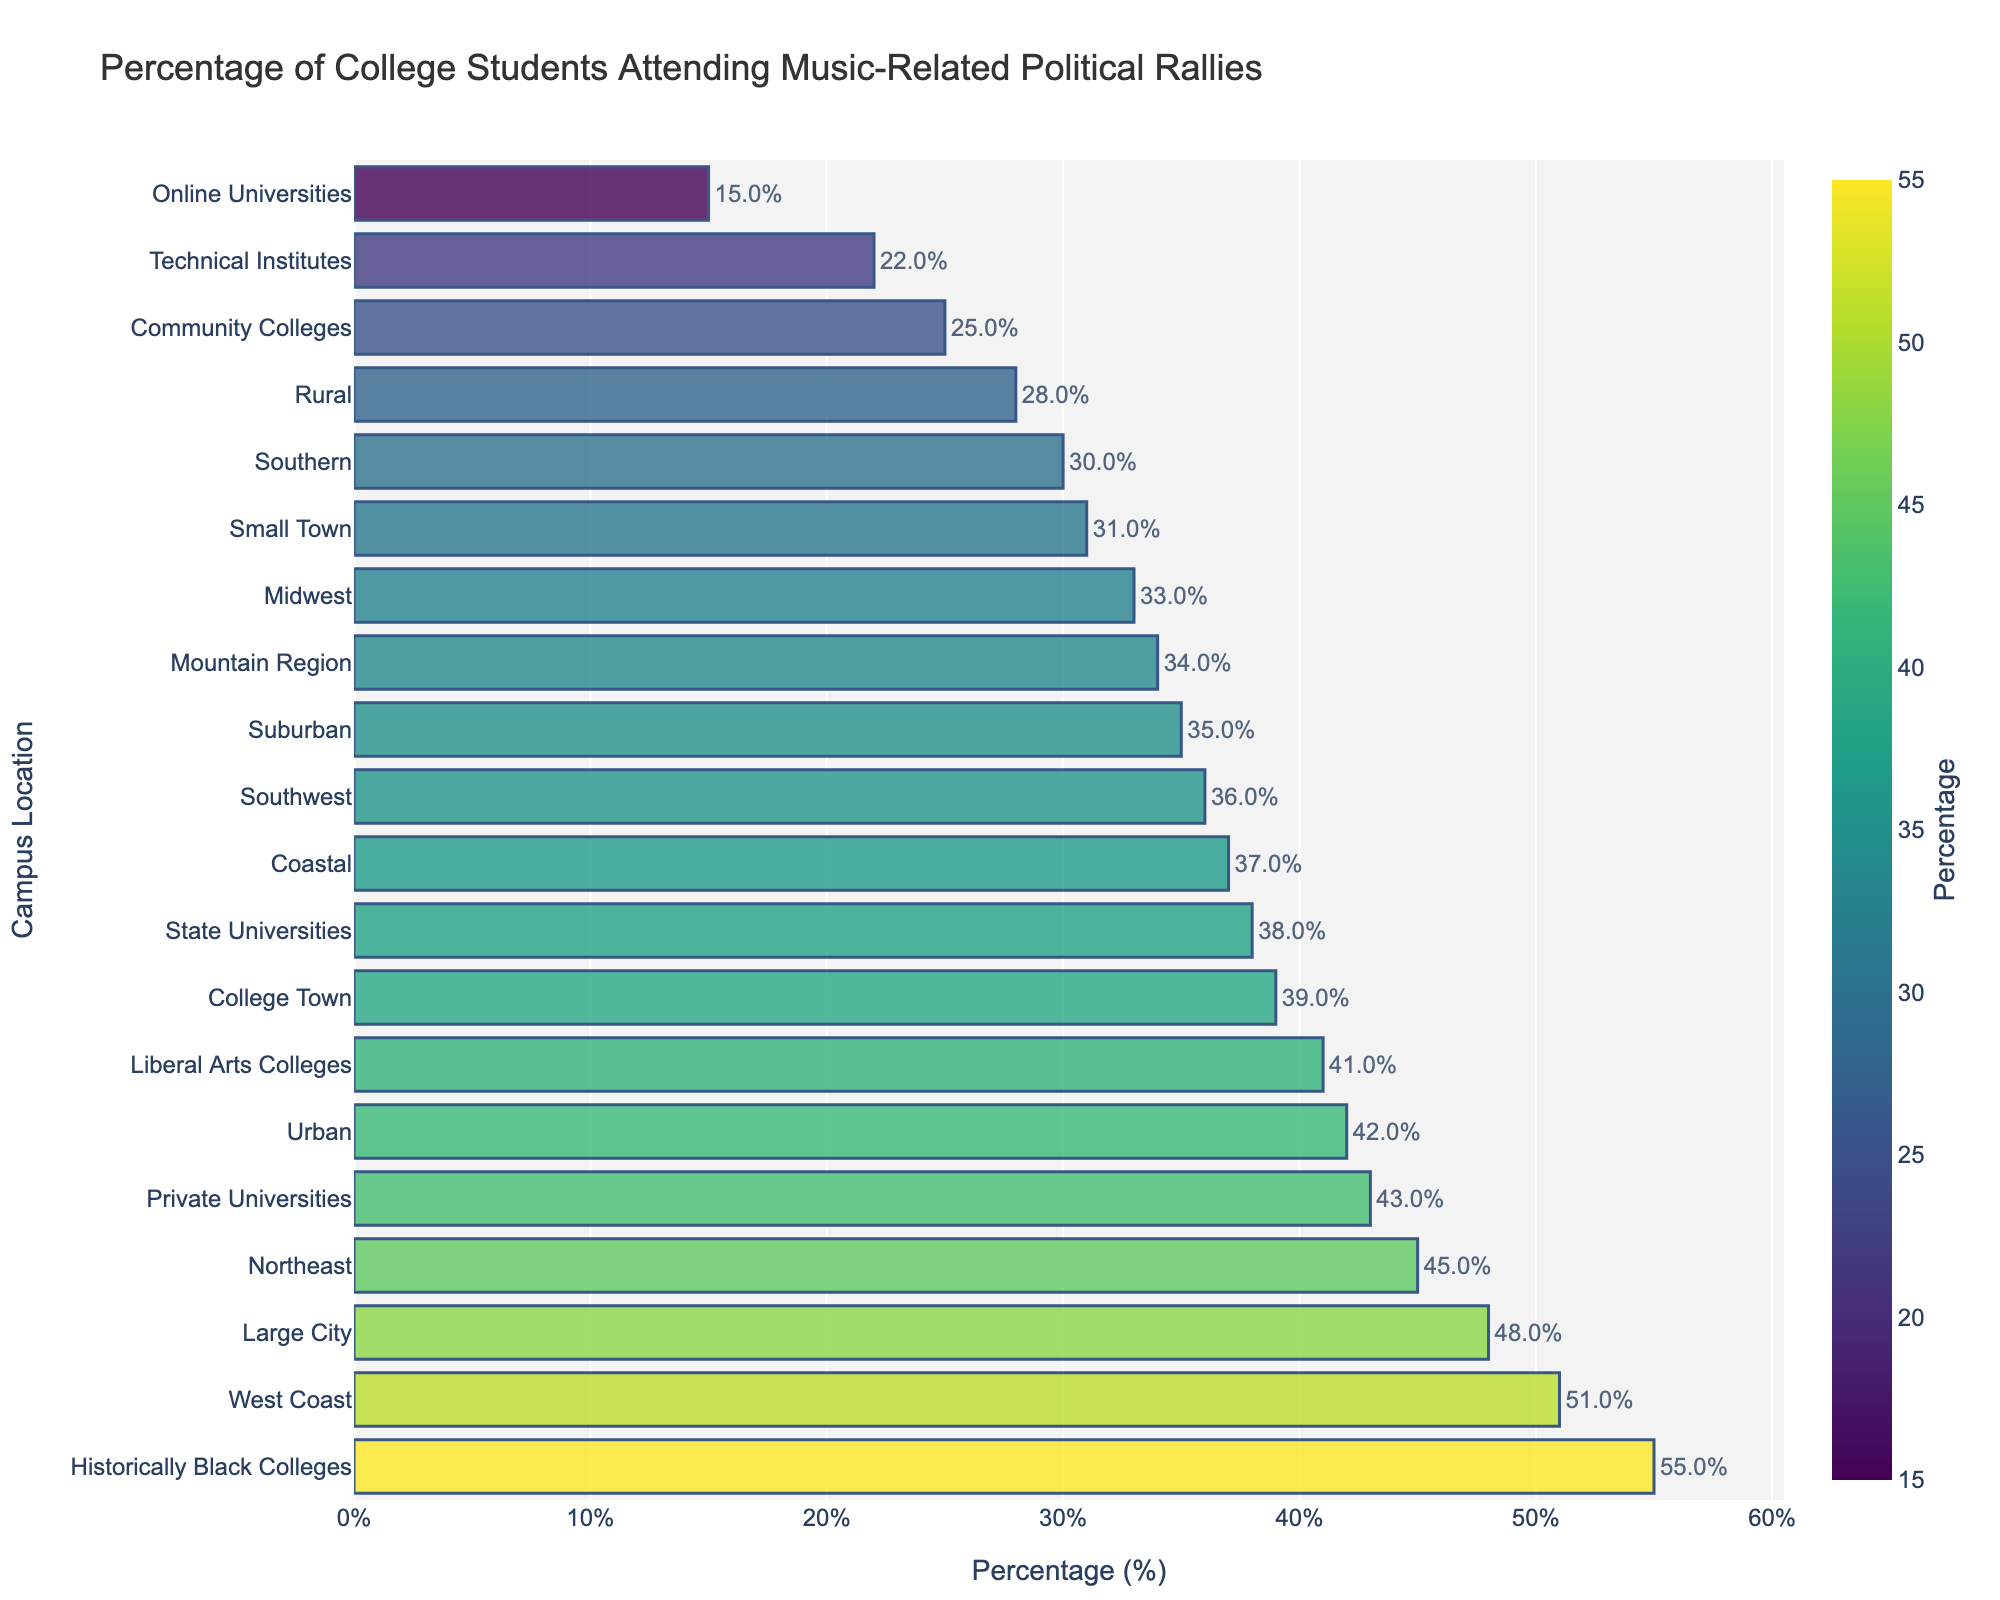What is the percentage difference between the highest and lowest percentages of college students attending music-related political rallies across campus locations? To find the difference between the highest and lowest percentages, we subtract the lowest value (Online Universities, 15%) from the highest value (Historically Black Colleges, 55%). The percentage difference is 55% - 15% = 40%.
Answer: 40% Which campus location has the highest percentage of students attending music-related political rallies? By examining the bar chart, the campus location with the highest percentage is Historically Black Colleges with 55%.
Answer: Historically Black Colleges Among Urban, Suburban, and Rural locations, which one has the highest participation rate in music-related political rallies? We compare the percentages of Urban (42%), Suburban (35%), and Rural (28%). Urban has the highest percentage.
Answer: Urban How does the percentage of students attending music-related political rallies in Private Universities compare to State Universities? From the bar chart, the percentage for Private Universities is 43% and for State Universities is 38%. The percentage for Private Universities is 5% higher than that for State Universities.
Answer: Private Universities are 5% higher What is the total percentage of students attending music-related political rallies from Northeast and Southwest combined? Sum the percentages of Northeast (45%) and Southwest (36%). The total percentage is 45% + 36% = 81%.
Answer: 81% Which campus locations have a participation rate above 50%? Looking at the bar chart, the locations with percentages above 50% are Historically Black Colleges (55%) and West Coast (51%).
Answer: Historically Black Colleges, West Coast Is the participation rate in Coastal locations higher or lower than that in Liberal Arts Colleges? Comparing the percentages, Coastal (37%) is lower than Liberal Arts Colleges (41%).
Answer: Lower What is the median percentage of students attending music-related political rallies for all campus locations? To find the median, we list all percentages in ascending order: 15, 22, 25, 28, 30, 31, 33, 34, 35, 36, 37, 38, 39, 41, 42, 43, 45, 48, 51, 55. The median is the middle value. With 20 data points, the median is the average of the 10th and 11th values: (36 + 37) / 2 = 36.5.
Answer: 36.5% How does the percentage of students attending music-related political rallies in Community Colleges compare to Technical Institutes? From the bar chart, Community Colleges have 25% and Technical Institutes have 22%. Community Colleges have a 3% higher participation rate than Technical Institutes.
Answer: Community Colleges are 3% higher What is the average participation rate across all campus locations? To find the average, sum the percentages for all campus locations: 42 + 35 + 28 + 31 + 48 + 39 + 37 + 33 + 30 + 45 + 51 + 34 + 36 + 55 + 41 + 38 + 43 + 25 + 22 + 15 = 727. Divide by the number of locations, 727 / 20 = 36.35%.
Answer: 36.35% 